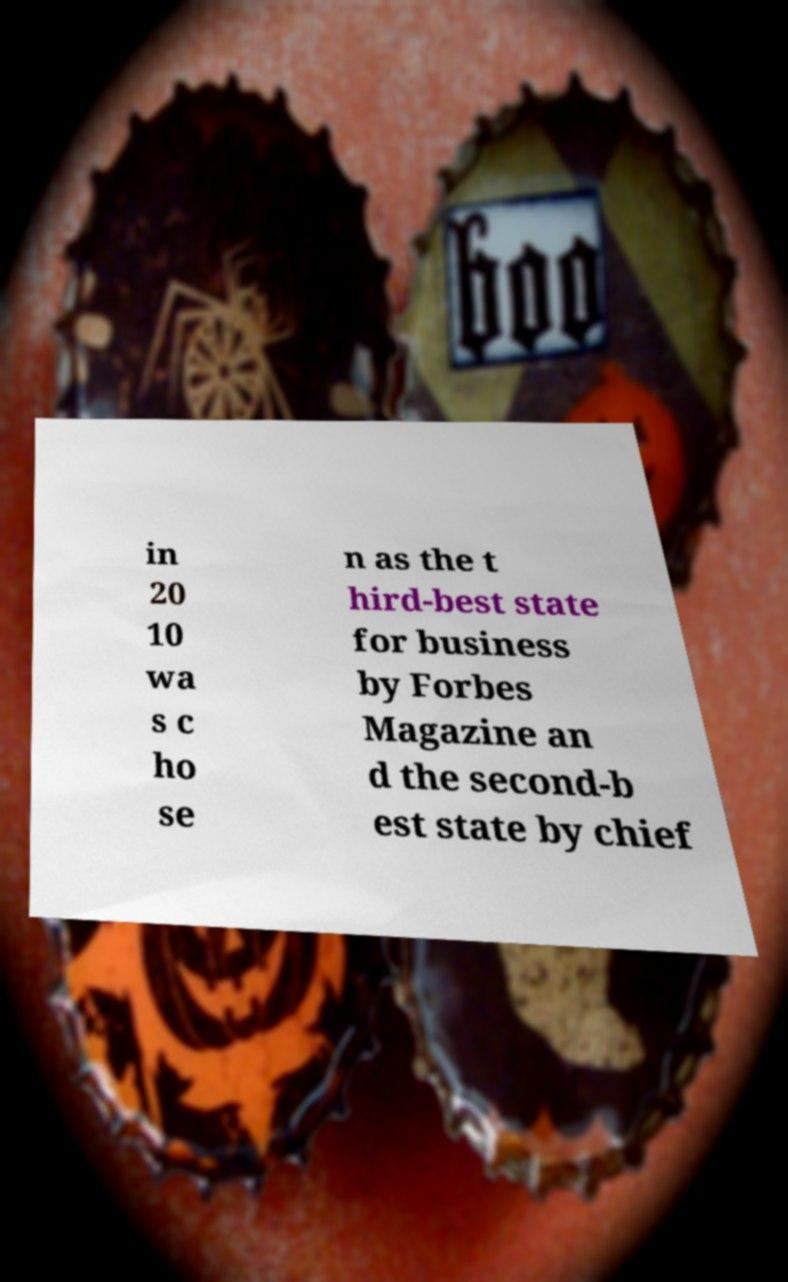Could you assist in decoding the text presented in this image and type it out clearly? in 20 10 wa s c ho se n as the t hird-best state for business by Forbes Magazine an d the second-b est state by chief 